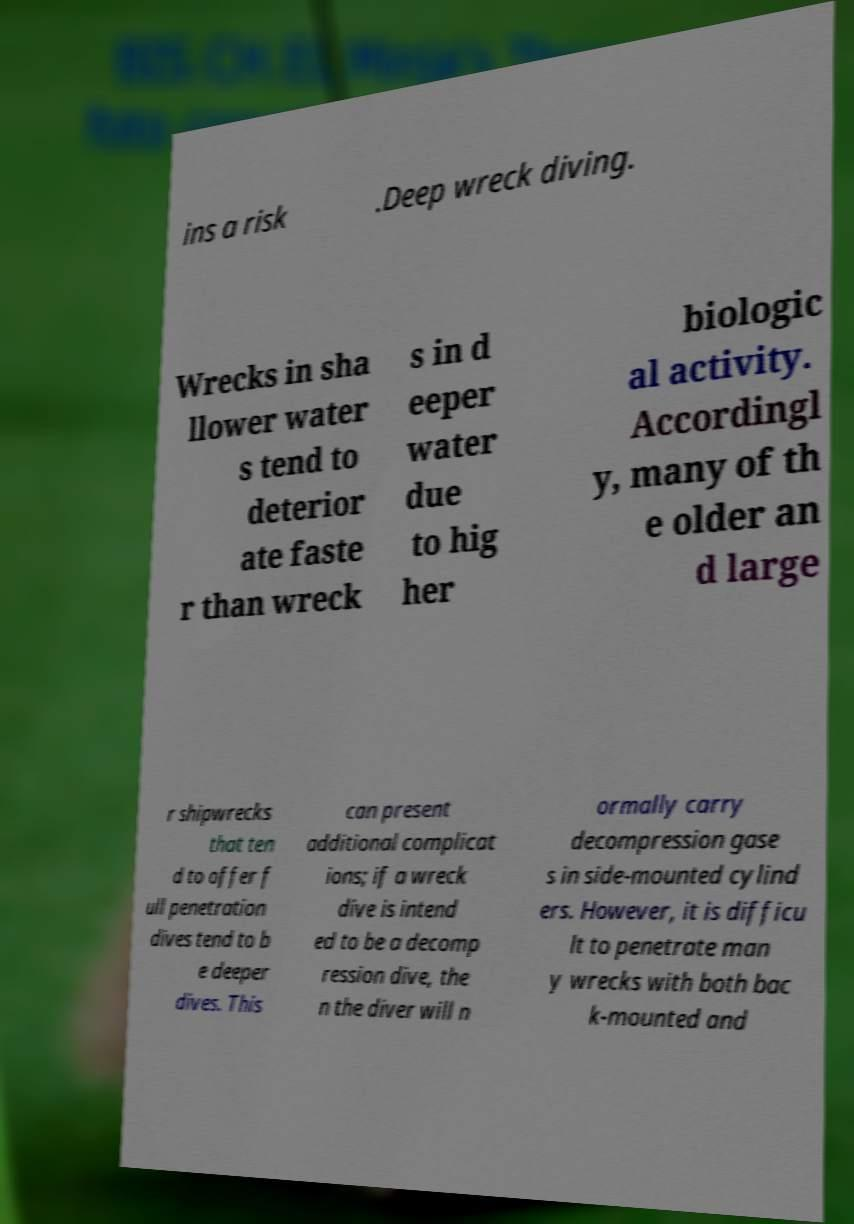Can you accurately transcribe the text from the provided image for me? ins a risk .Deep wreck diving. Wrecks in sha llower water s tend to deterior ate faste r than wreck s in d eeper water due to hig her biologic al activity. Accordingl y, many of th e older an d large r shipwrecks that ten d to offer f ull penetration dives tend to b e deeper dives. This can present additional complicat ions; if a wreck dive is intend ed to be a decomp ression dive, the n the diver will n ormally carry decompression gase s in side-mounted cylind ers. However, it is difficu lt to penetrate man y wrecks with both bac k-mounted and 